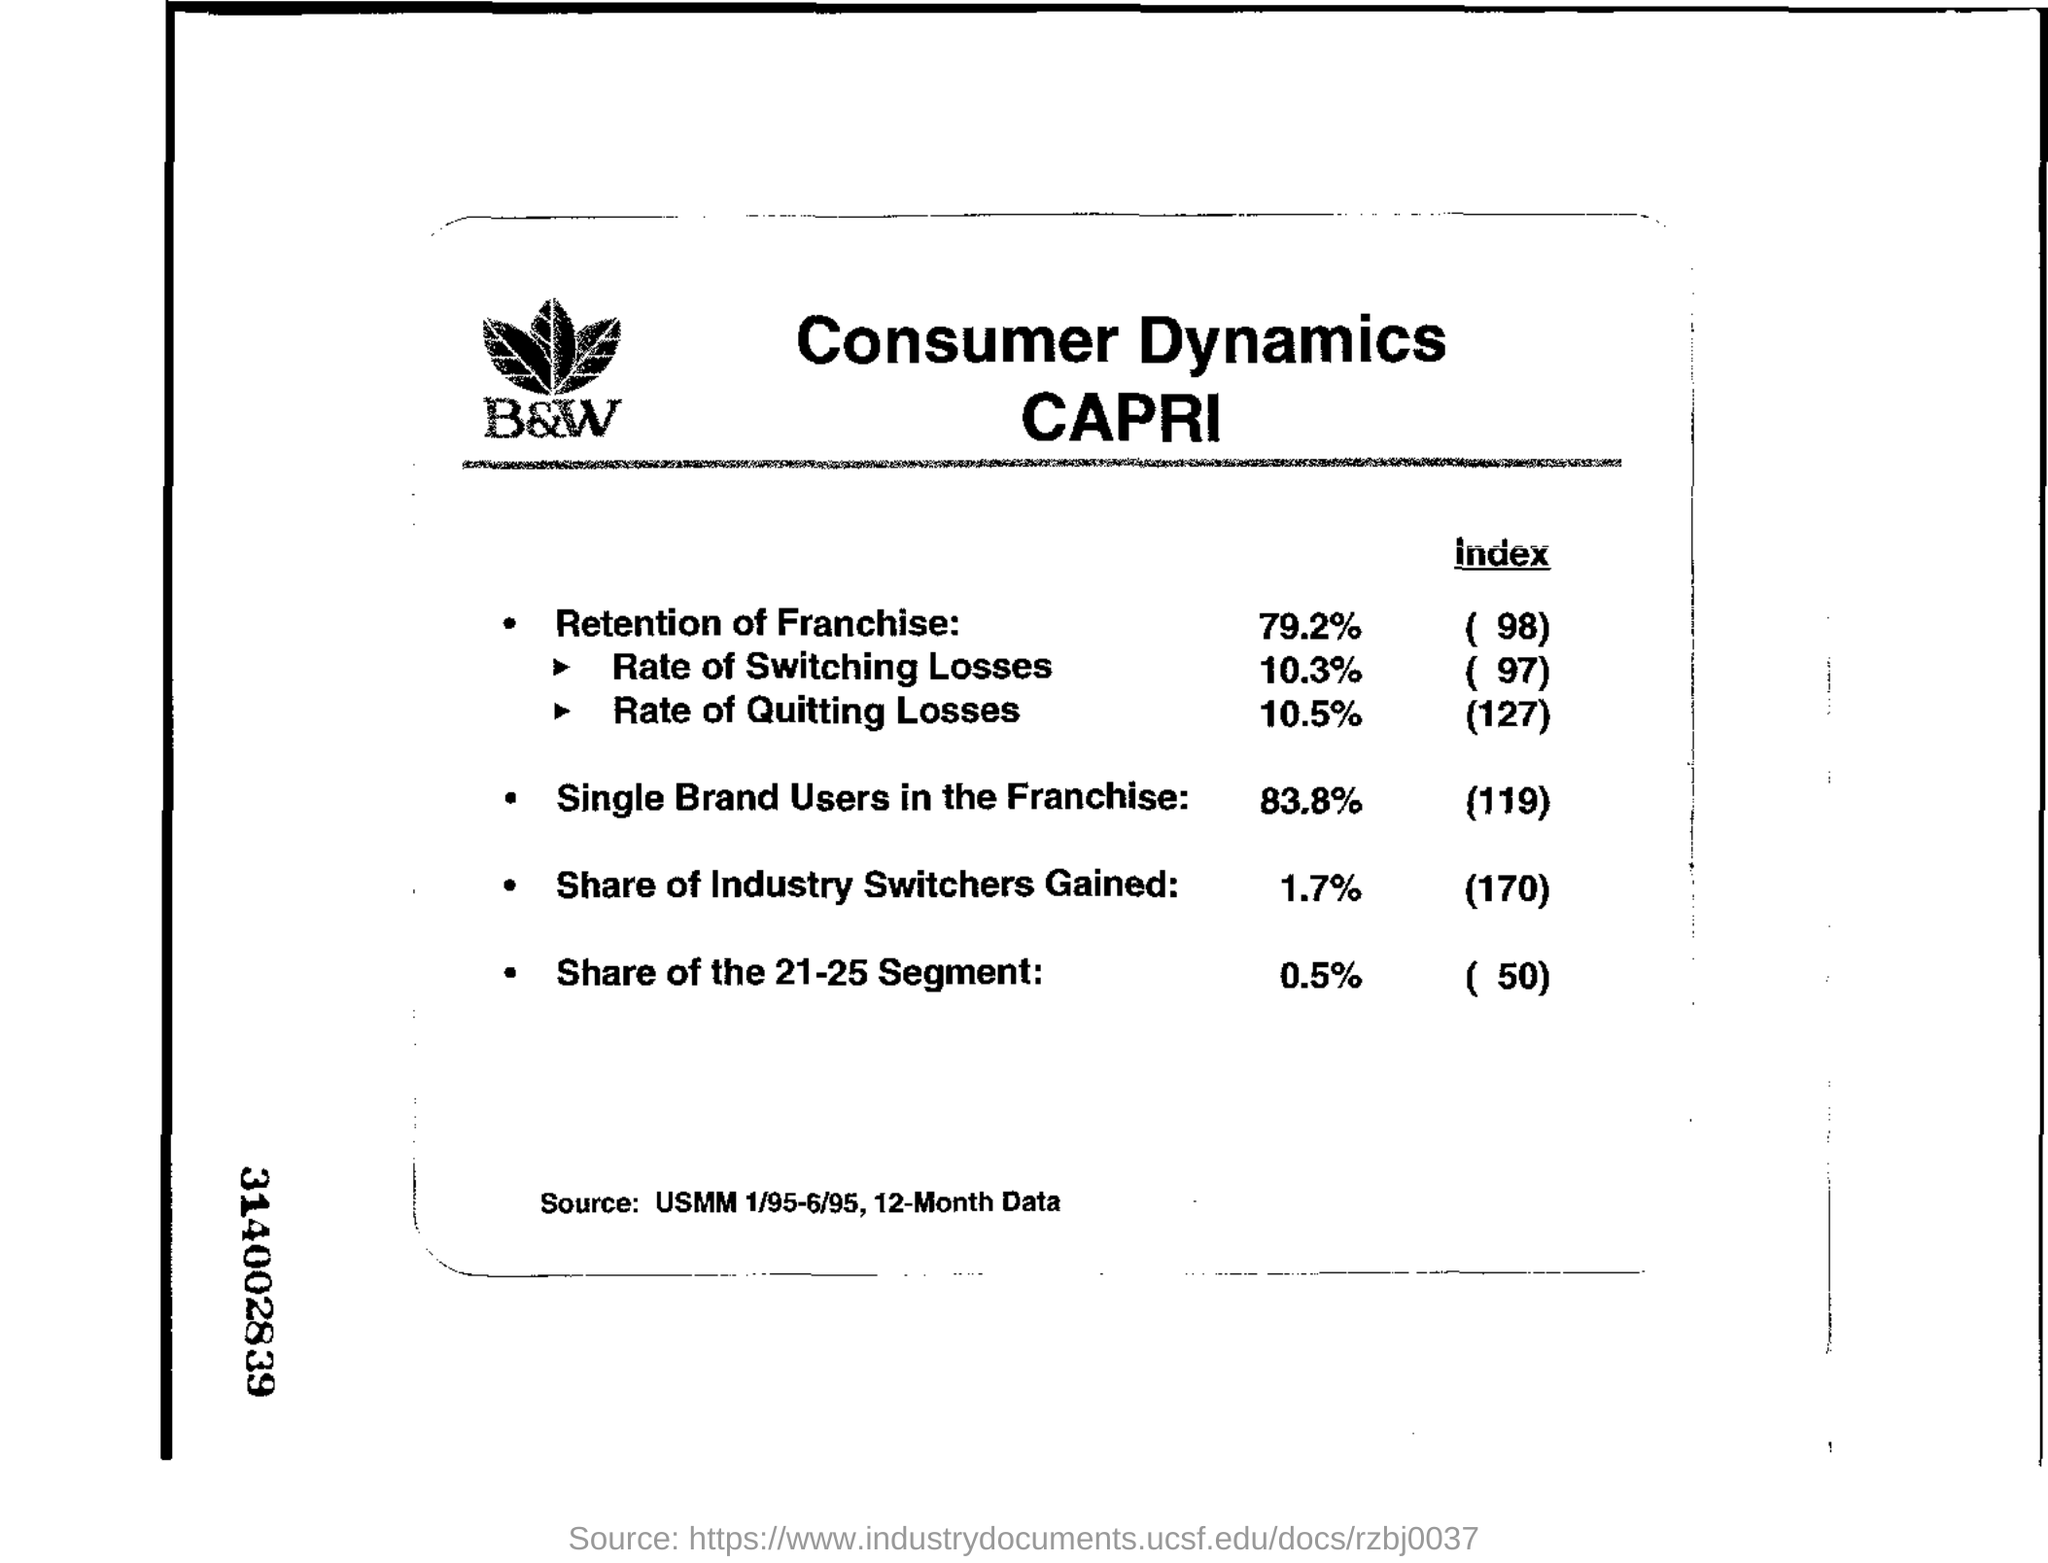How many months have the data given here been extracted?
Ensure brevity in your answer.  12. What is the Retention of Franchise?
Ensure brevity in your answer.  79.2%. What is the Index of Single Brand Users in the Franchise?
Your response must be concise. 119. What is the share of the 21-25 segment mentioned?
Your answer should be compact. 0.5%. 